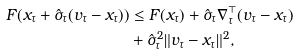<formula> <loc_0><loc_0><loc_500><loc_500>F ( x _ { \tau } + \hat { \sigma } _ { \tau } ( v _ { \tau } - x _ { \tau } ) ) & \leq F ( x _ { \tau } ) + \hat { \sigma } _ { \tau } \nabla _ { \tau } ^ { \top } ( v _ { \tau } - x _ { \tau } ) \\ & + \hat { \sigma } _ { \tau } ^ { 2 } \| v _ { \tau } - x _ { \tau } \| ^ { 2 } ,</formula> 